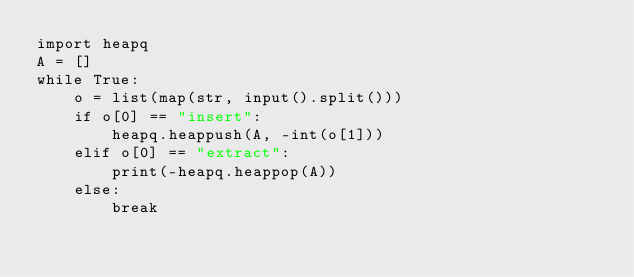<code> <loc_0><loc_0><loc_500><loc_500><_Python_>import heapq
A = []
while True:
	o = list(map(str, input().split()))
	if o[0] == "insert":
		heapq.heappush(A, -int(o[1]))
	elif o[0] == "extract":
		print(-heapq.heappop(A))
	else:
		break</code> 